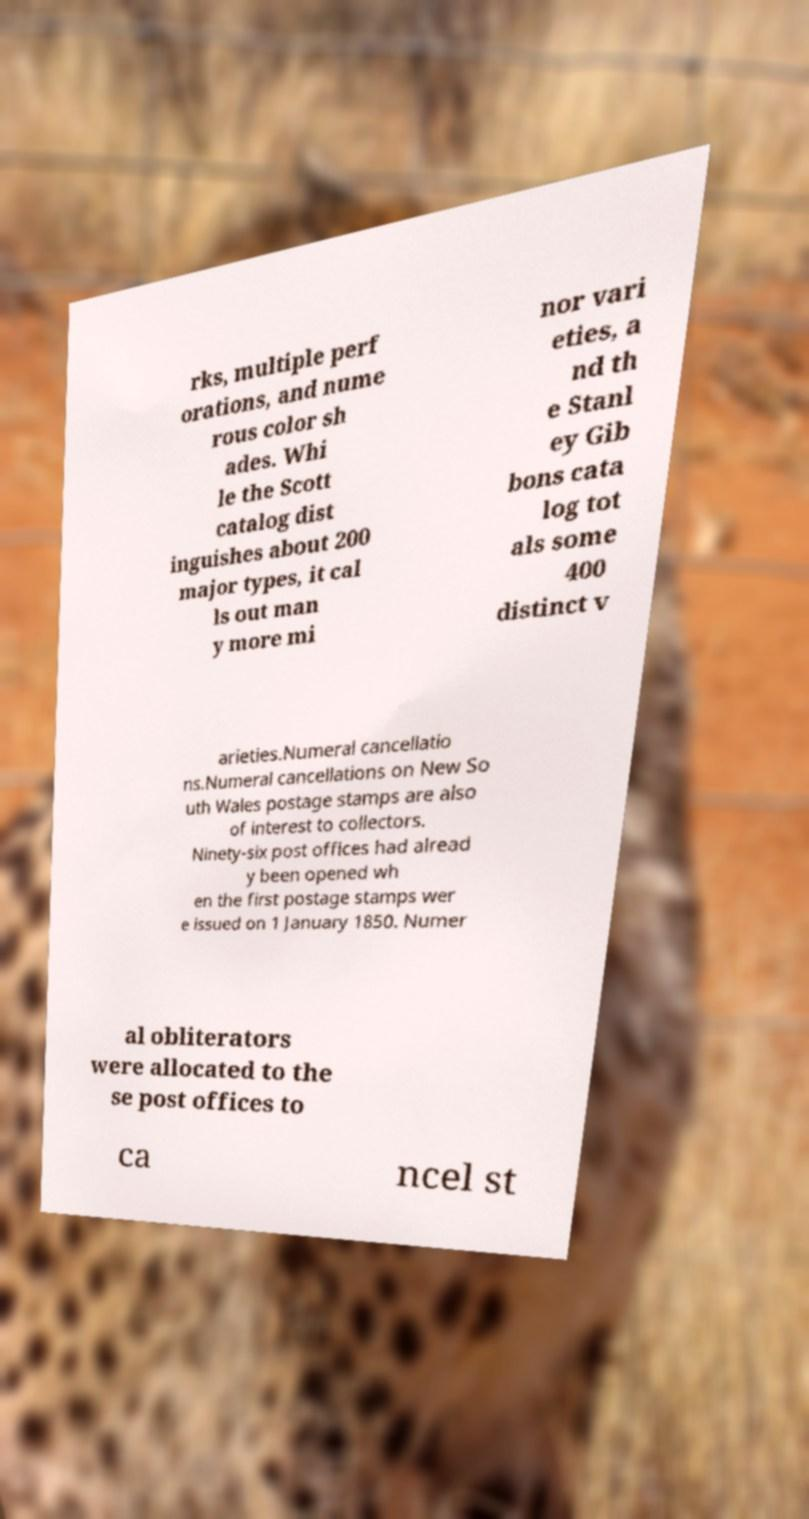Can you accurately transcribe the text from the provided image for me? rks, multiple perf orations, and nume rous color sh ades. Whi le the Scott catalog dist inguishes about 200 major types, it cal ls out man y more mi nor vari eties, a nd th e Stanl ey Gib bons cata log tot als some 400 distinct v arieties.Numeral cancellatio ns.Numeral cancellations on New So uth Wales postage stamps are also of interest to collectors. Ninety-six post offices had alread y been opened wh en the first postage stamps wer e issued on 1 January 1850. Numer al obliterators were allocated to the se post offices to ca ncel st 